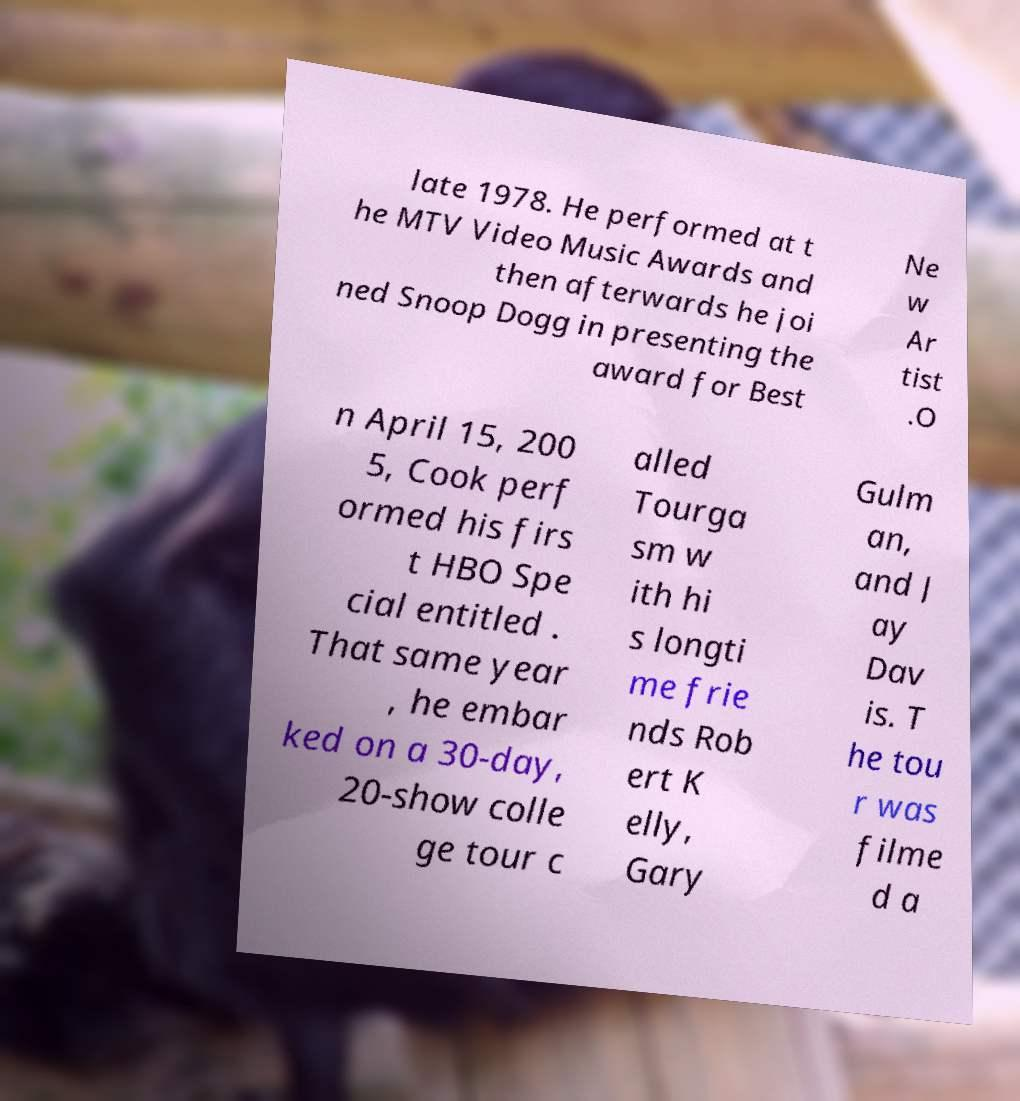I need the written content from this picture converted into text. Can you do that? late 1978. He performed at t he MTV Video Music Awards and then afterwards he joi ned Snoop Dogg in presenting the award for Best Ne w Ar tist .O n April 15, 200 5, Cook perf ormed his firs t HBO Spe cial entitled . That same year , he embar ked on a 30-day, 20-show colle ge tour c alled Tourga sm w ith hi s longti me frie nds Rob ert K elly, Gary Gulm an, and J ay Dav is. T he tou r was filme d a 